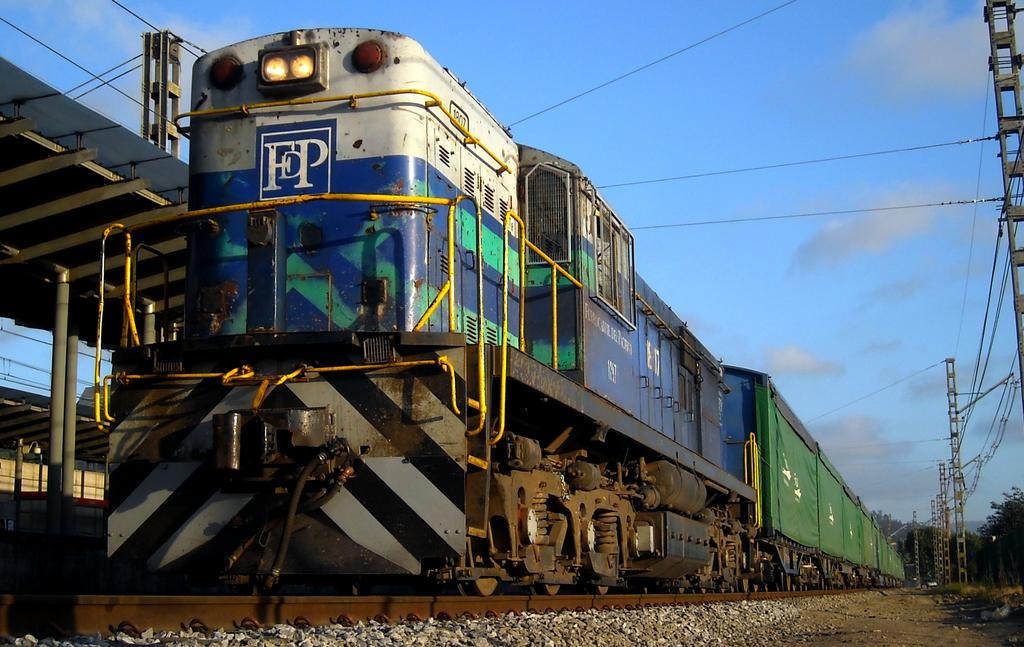What is the main subject of the image? The main subject of the image is a train. Where is the train located? The train is on a railway track. What can be seen around the train? There are towers with wires around the train. What is behind the train? There is a platform behind the train. What type of support can be seen holding up the soup in the image? There is no soup present in the image, and therefore no support for it. 